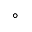Convert formula to latex. <formula><loc_0><loc_0><loc_500><loc_500>\circ</formula> 